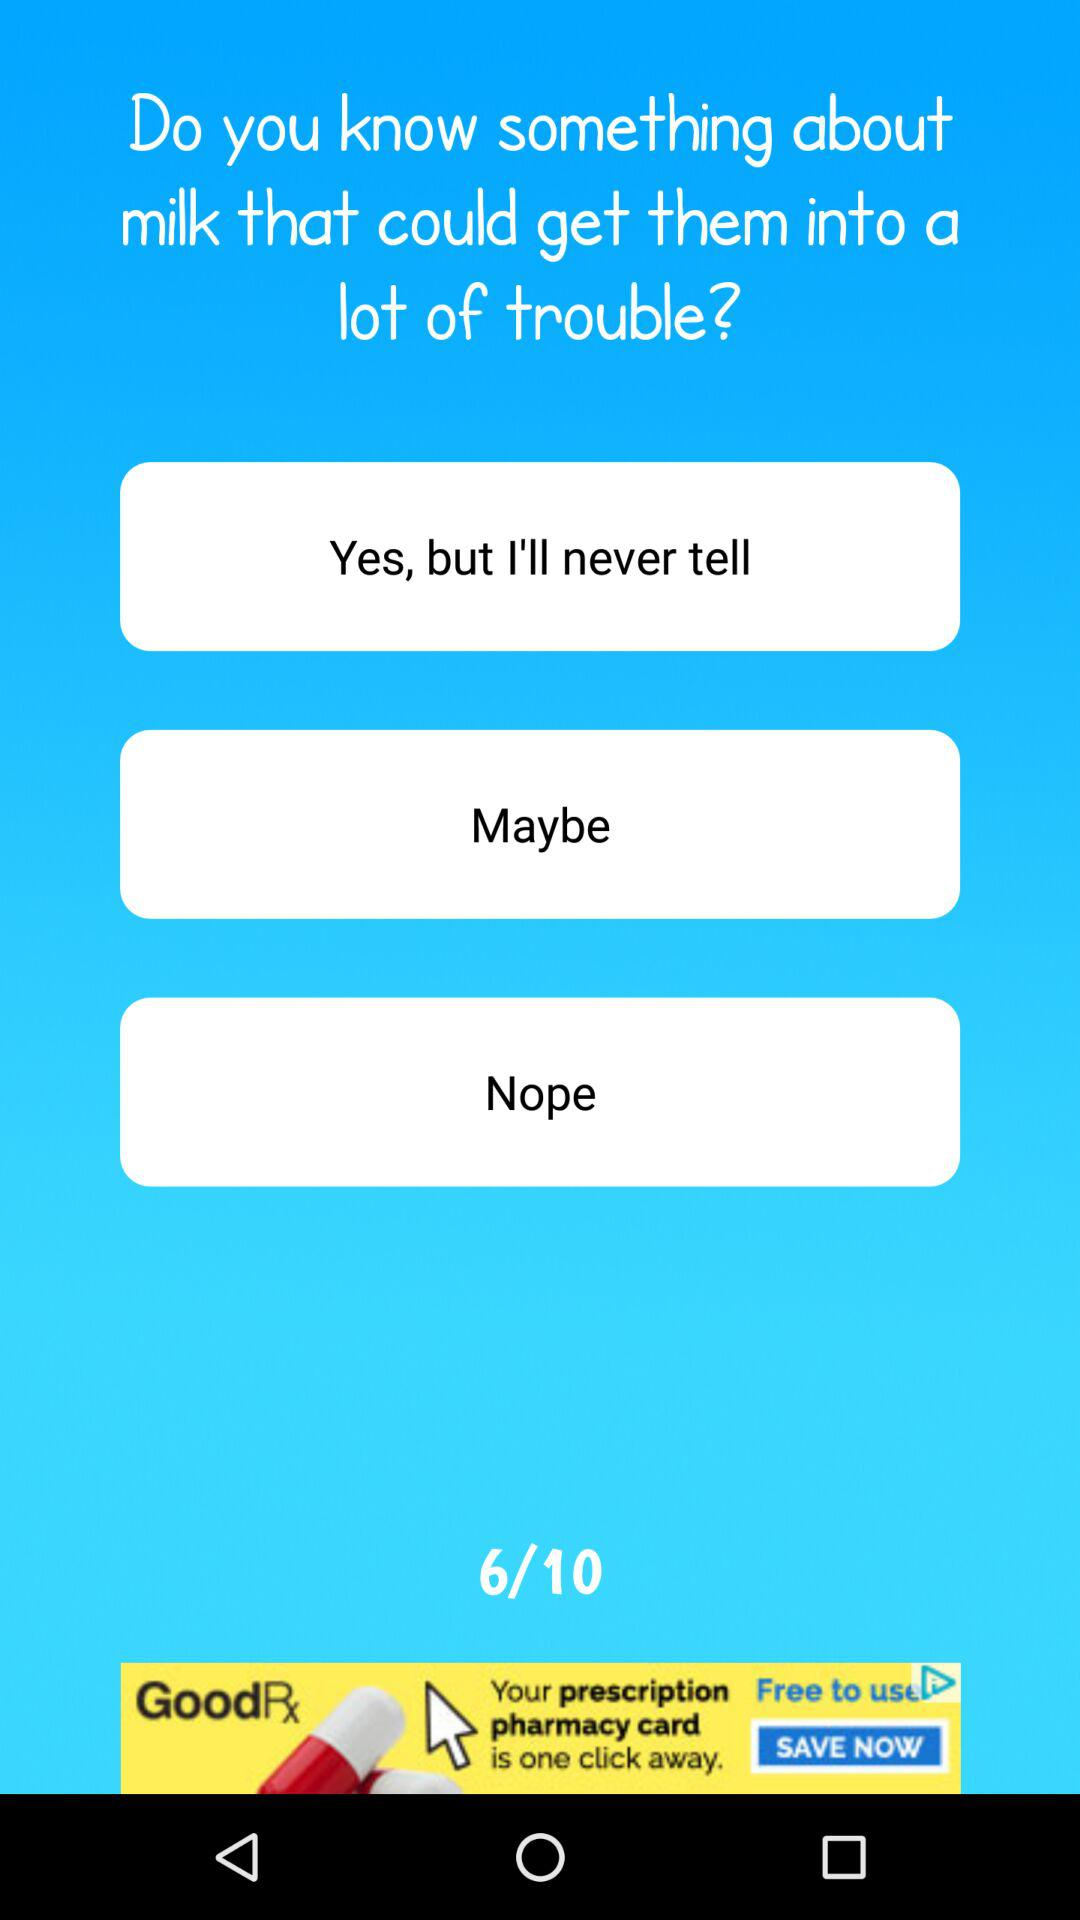How many questions have been answered out of 10? The number of questions that have been answered is 6. 